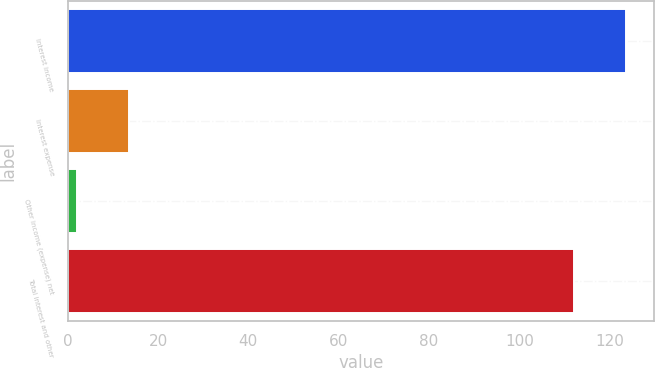Convert chart. <chart><loc_0><loc_0><loc_500><loc_500><bar_chart><fcel>Interest income<fcel>Interest expense<fcel>Other income (expense) net<fcel>Total interest and other<nl><fcel>123.6<fcel>13.6<fcel>2<fcel>112<nl></chart> 